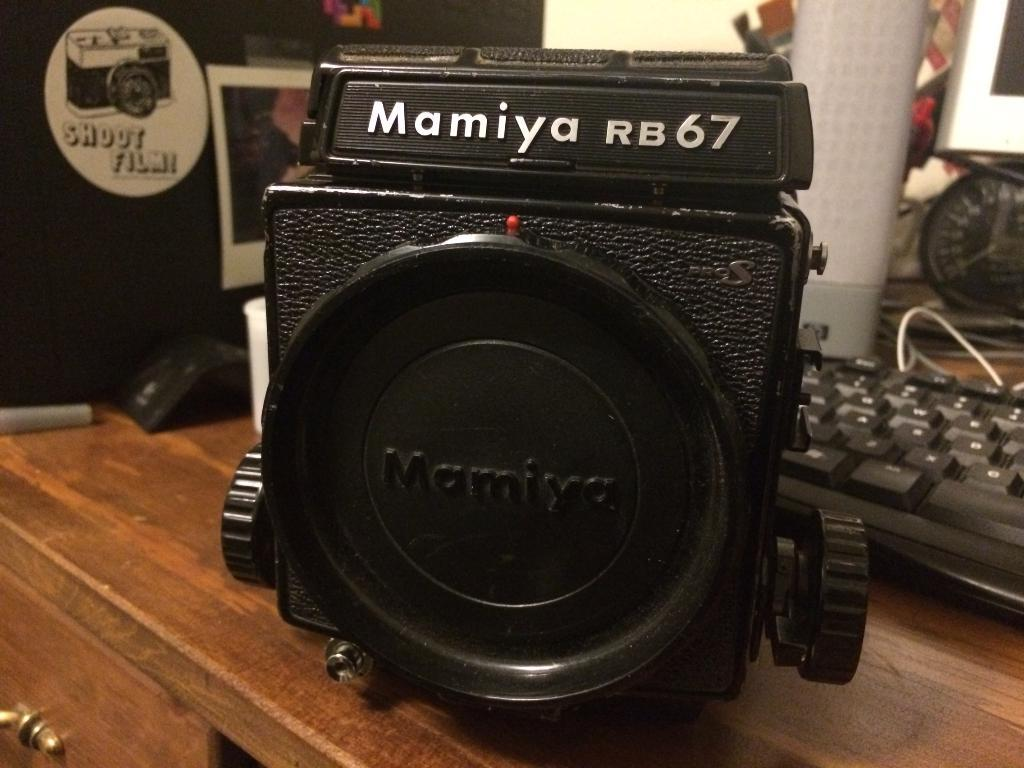Provide a one-sentence caption for the provided image. A camera lens showing the model number Mamiya RB67. 